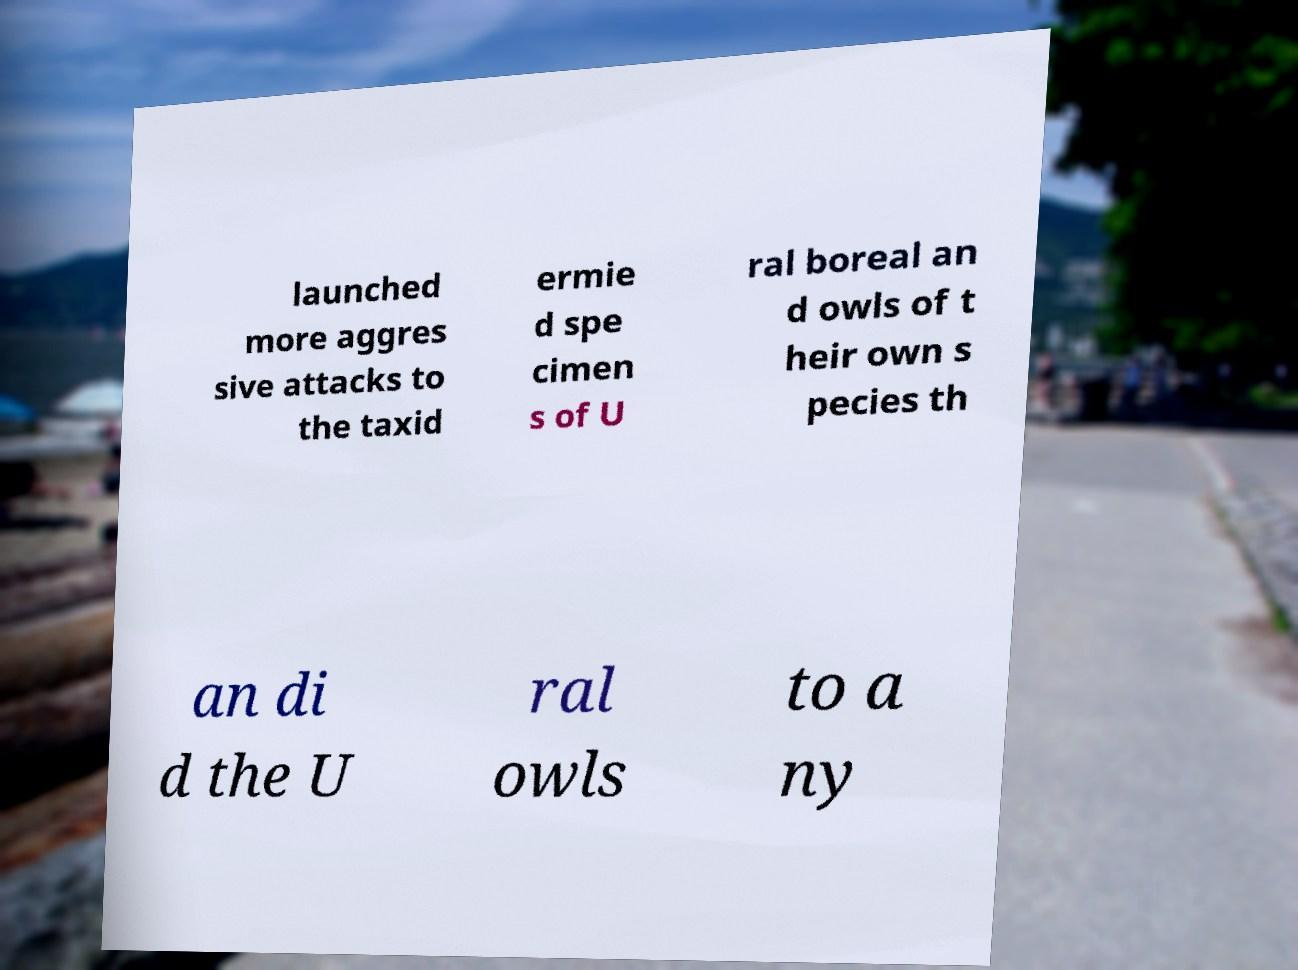Please identify and transcribe the text found in this image. launched more aggres sive attacks to the taxid ermie d spe cimen s of U ral boreal an d owls of t heir own s pecies th an di d the U ral owls to a ny 